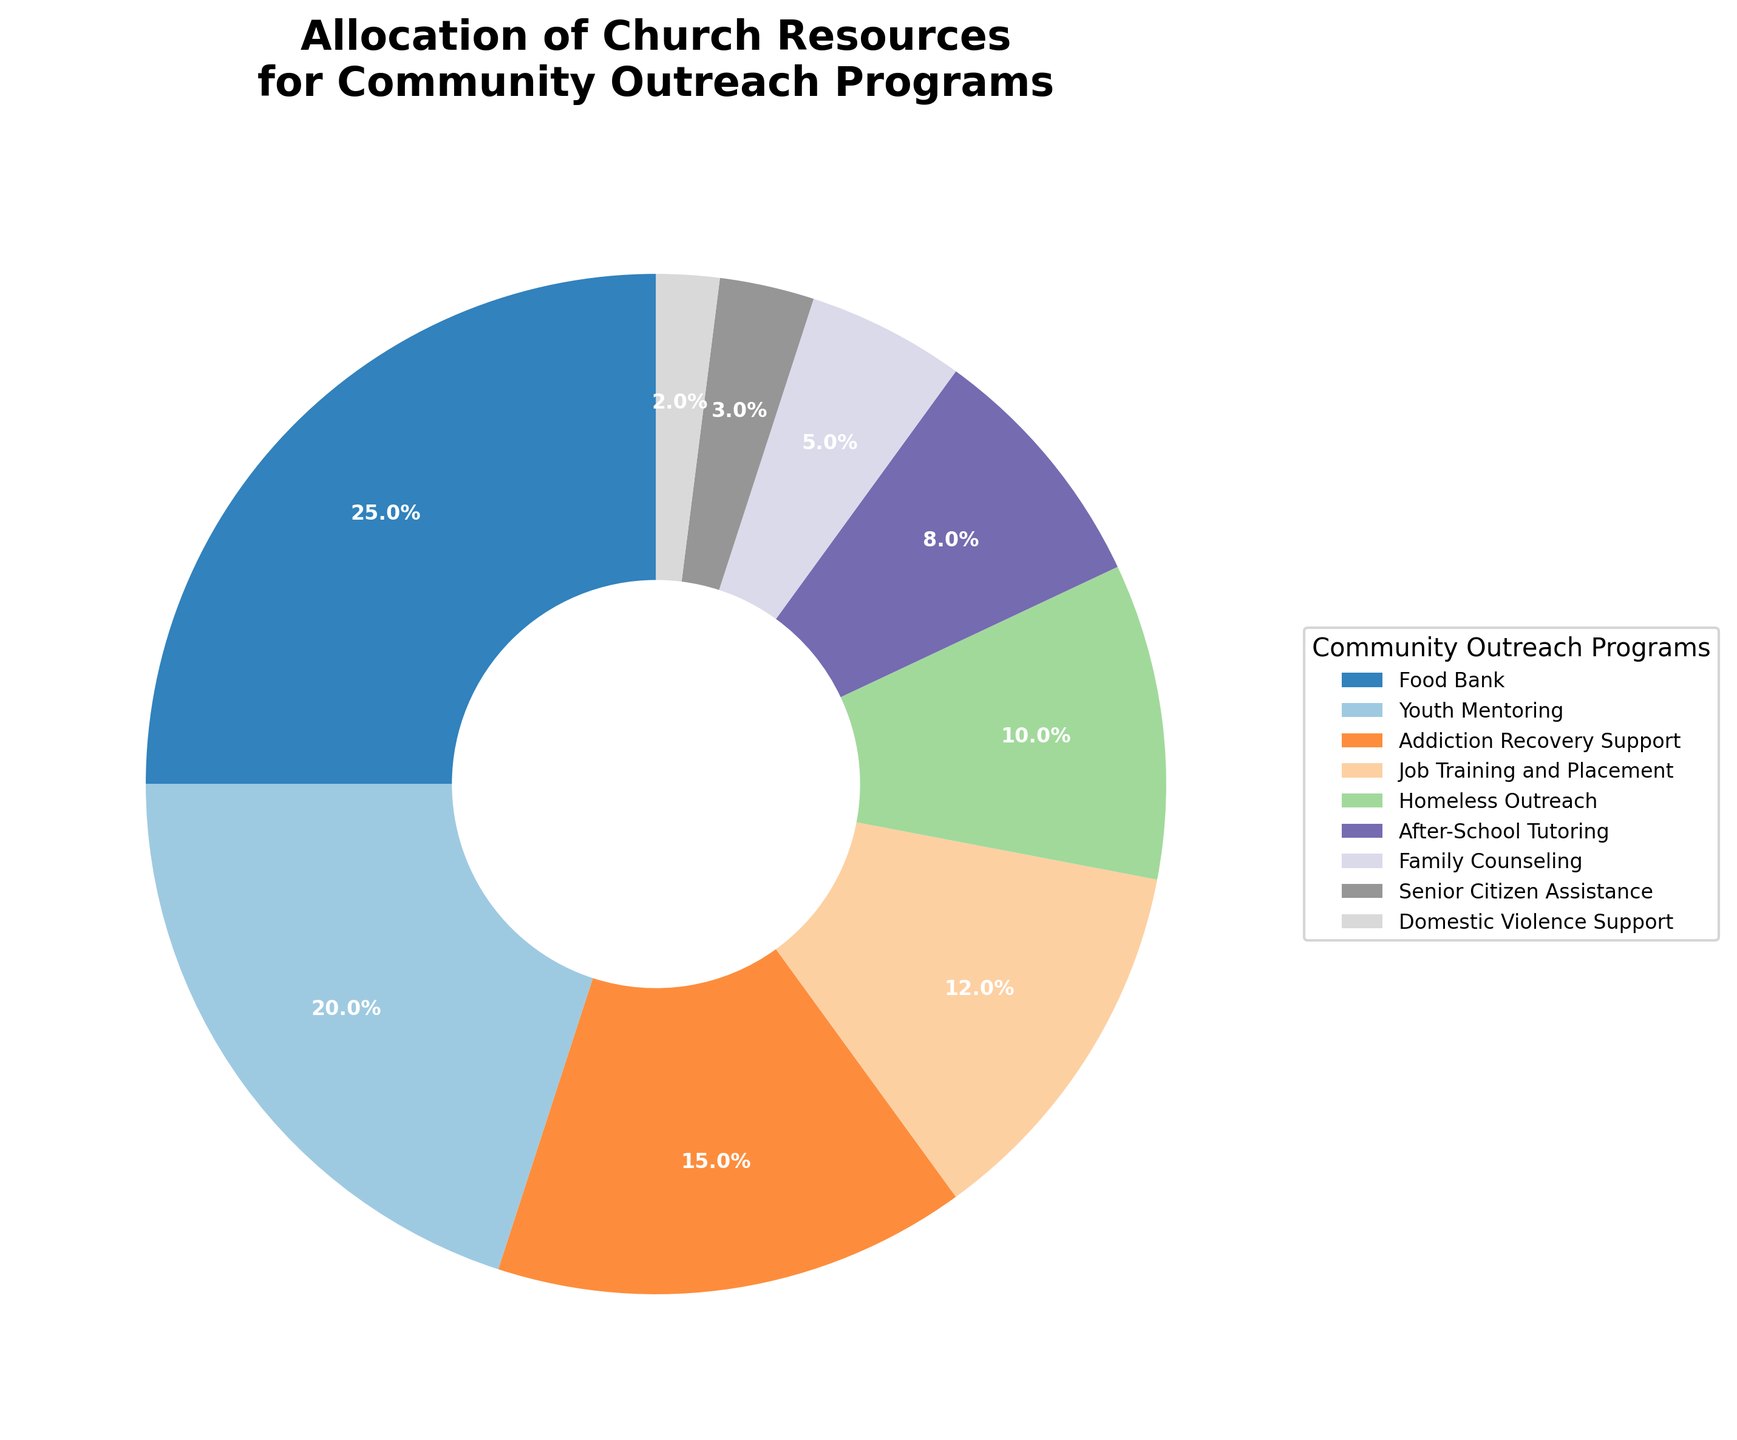Which program receives the highest percentage of resources? Looking at the slices of the pie chart, identify the program with the largest slice. This is typically labeled and should have the highest percentage.
Answer: Food Bank What's the combined percentage for Youth Mentoring and Addiction Recovery Support? Add the individual percentages for Youth Mentoring (20%) and Addiction Recovery Support (15%).
Answer: 35% Which program gets more resources: Job Training and Placement or After-School Tutoring? Compare the two slices. Job Training and Placement has 12%, and After-School Tutoring has 8%.
Answer: Job Training and Placement How much more percentage of resources is allocated to Homeless Outreach compared to Senior Citizen Assistance? Subtract the percentage of Senior Citizen Assistance (3%) from Homeless Outreach (10%).
Answer: 7% Which program receives the least resources? Look for the smallest slice on the pie chart, which is typically labeled and has the lowest percentage.
Answer: Domestic Violence Support What is the visual difference between the Food Bank and Family Counseling slices in terms of size and percentage? The Food Bank slice is much larger, with 25%, compared to the smaller Family Counseling slice, which has 5%.
Answer: Food Bank's slice is larger with 25% vs Family Counseling's 5% What percentage of resources is allocated to programs specifically aimed at supporting different age groups (Youth Mentoring, After-School Tutoring, Senior Citizen Assistance)? Sum the percentages for Youth Mentoring (20%), After-School Tutoring (8%), and Senior Citizen Assistance (3%).
Answer: 31% Which program falls right in the middle in terms of percentage allocation? Arrange the programs by percentage and identify the middle value. In this case, Job Training and Placement, with 12%, falls in the middle.
Answer: Job Training and Placement Is the combined percentage allocated to Family Counseling and Domestic Violence Support more or less than Addiction Recovery Support? Sum Family Counseling (5%) and Domestic Violence Support (2%) to get 7%, which is less than Addiction Recovery Support's 15%.
Answer: Less What's the ratio of resources allocated to Food Bank compared to Job Training and Placement? Divide the percentage for Food Bank (25%) by Job Training and Placement (12%) to get the ratio.
Answer: 25:12 or approximately 2.08:1 